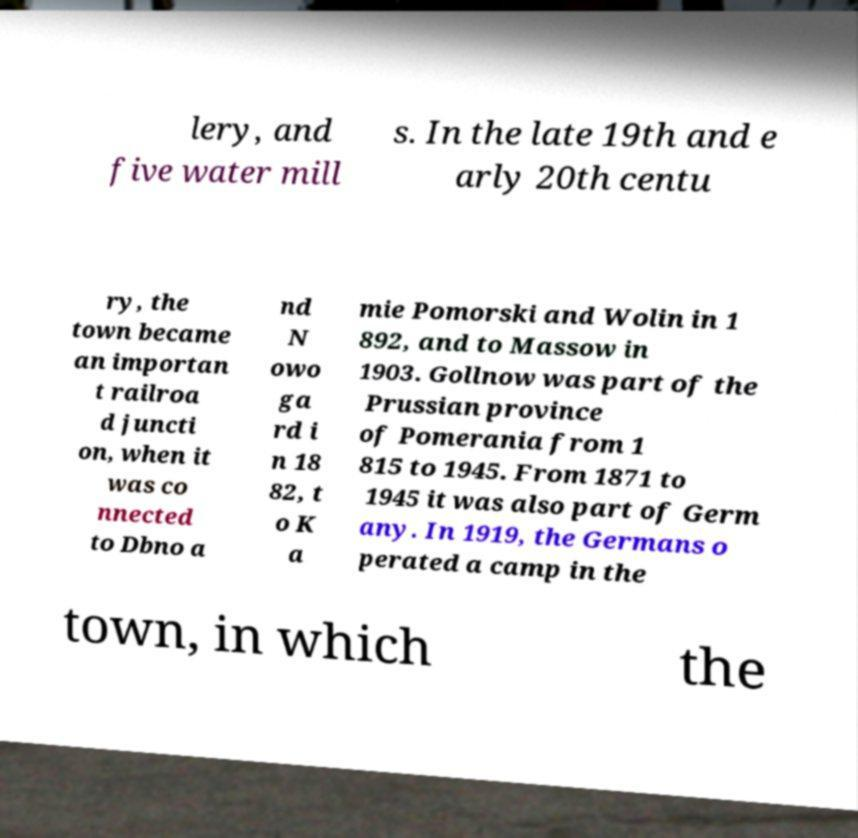Please identify and transcribe the text found in this image. lery, and five water mill s. In the late 19th and e arly 20th centu ry, the town became an importan t railroa d juncti on, when it was co nnected to Dbno a nd N owo ga rd i n 18 82, t o K a mie Pomorski and Wolin in 1 892, and to Massow in 1903. Gollnow was part of the Prussian province of Pomerania from 1 815 to 1945. From 1871 to 1945 it was also part of Germ any. In 1919, the Germans o perated a camp in the town, in which the 